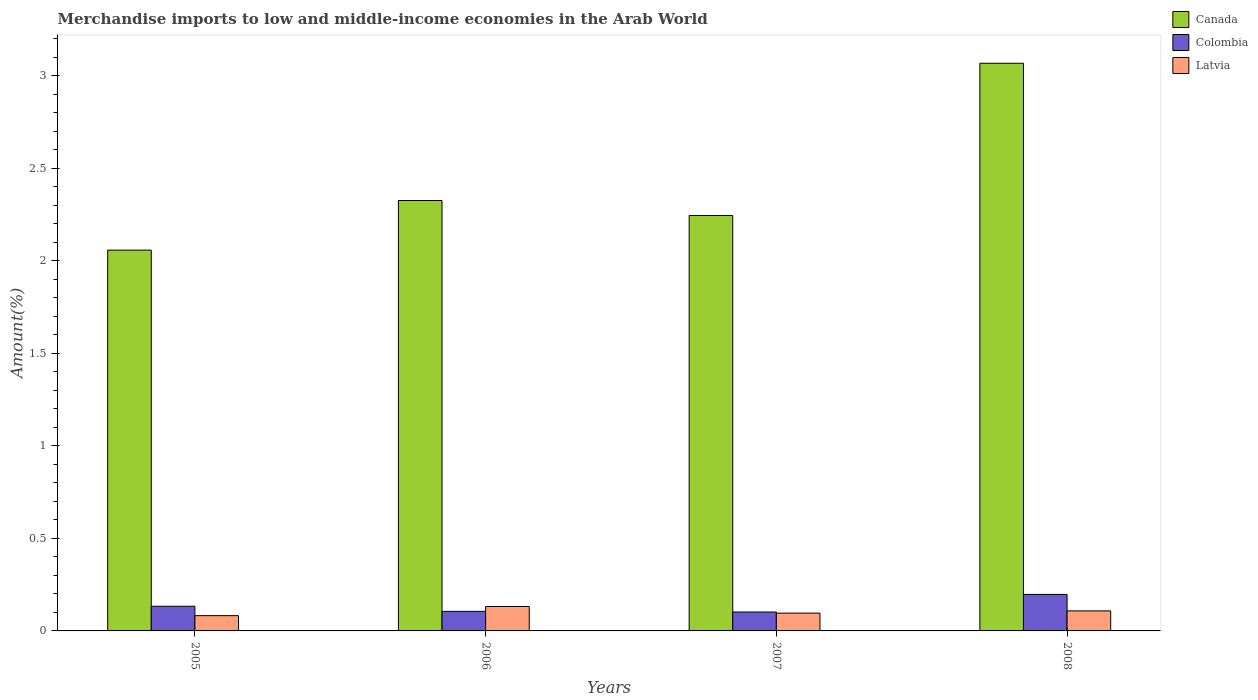How many different coloured bars are there?
Your answer should be very brief. 3. How many groups of bars are there?
Ensure brevity in your answer.  4. How many bars are there on the 2nd tick from the left?
Your answer should be very brief. 3. What is the label of the 1st group of bars from the left?
Provide a short and direct response. 2005. What is the percentage of amount earned from merchandise imports in Colombia in 2008?
Offer a very short reply. 0.2. Across all years, what is the maximum percentage of amount earned from merchandise imports in Latvia?
Give a very brief answer. 0.13. Across all years, what is the minimum percentage of amount earned from merchandise imports in Colombia?
Offer a very short reply. 0.1. In which year was the percentage of amount earned from merchandise imports in Canada maximum?
Provide a succinct answer. 2008. In which year was the percentage of amount earned from merchandise imports in Canada minimum?
Your answer should be compact. 2005. What is the total percentage of amount earned from merchandise imports in Latvia in the graph?
Ensure brevity in your answer.  0.42. What is the difference between the percentage of amount earned from merchandise imports in Latvia in 2006 and that in 2007?
Your answer should be very brief. 0.04. What is the difference between the percentage of amount earned from merchandise imports in Colombia in 2008 and the percentage of amount earned from merchandise imports in Canada in 2005?
Keep it short and to the point. -1.86. What is the average percentage of amount earned from merchandise imports in Colombia per year?
Your answer should be very brief. 0.13. In the year 2008, what is the difference between the percentage of amount earned from merchandise imports in Canada and percentage of amount earned from merchandise imports in Colombia?
Your answer should be compact. 2.87. In how many years, is the percentage of amount earned from merchandise imports in Colombia greater than 1.9 %?
Your response must be concise. 0. What is the ratio of the percentage of amount earned from merchandise imports in Canada in 2005 to that in 2006?
Your answer should be very brief. 0.88. Is the percentage of amount earned from merchandise imports in Colombia in 2005 less than that in 2006?
Offer a terse response. No. What is the difference between the highest and the second highest percentage of amount earned from merchandise imports in Colombia?
Provide a short and direct response. 0.06. What is the difference between the highest and the lowest percentage of amount earned from merchandise imports in Latvia?
Give a very brief answer. 0.05. What does the 1st bar from the left in 2006 represents?
Your answer should be very brief. Canada. What does the 1st bar from the right in 2007 represents?
Offer a terse response. Latvia. Are all the bars in the graph horizontal?
Provide a short and direct response. No. How many years are there in the graph?
Ensure brevity in your answer.  4. What is the difference between two consecutive major ticks on the Y-axis?
Give a very brief answer. 0.5. Where does the legend appear in the graph?
Make the answer very short. Top right. How are the legend labels stacked?
Your answer should be very brief. Vertical. What is the title of the graph?
Your answer should be compact. Merchandise imports to low and middle-income economies in the Arab World. What is the label or title of the X-axis?
Offer a very short reply. Years. What is the label or title of the Y-axis?
Give a very brief answer. Amount(%). What is the Amount(%) of Canada in 2005?
Ensure brevity in your answer.  2.06. What is the Amount(%) in Colombia in 2005?
Offer a very short reply. 0.13. What is the Amount(%) in Latvia in 2005?
Your answer should be very brief. 0.08. What is the Amount(%) in Canada in 2006?
Keep it short and to the point. 2.33. What is the Amount(%) of Colombia in 2006?
Keep it short and to the point. 0.11. What is the Amount(%) in Latvia in 2006?
Your response must be concise. 0.13. What is the Amount(%) in Canada in 2007?
Keep it short and to the point. 2.25. What is the Amount(%) of Colombia in 2007?
Ensure brevity in your answer.  0.1. What is the Amount(%) of Latvia in 2007?
Provide a short and direct response. 0.1. What is the Amount(%) of Canada in 2008?
Keep it short and to the point. 3.07. What is the Amount(%) of Colombia in 2008?
Provide a succinct answer. 0.2. What is the Amount(%) of Latvia in 2008?
Provide a succinct answer. 0.11. Across all years, what is the maximum Amount(%) of Canada?
Make the answer very short. 3.07. Across all years, what is the maximum Amount(%) of Colombia?
Your response must be concise. 0.2. Across all years, what is the maximum Amount(%) in Latvia?
Your answer should be very brief. 0.13. Across all years, what is the minimum Amount(%) in Canada?
Keep it short and to the point. 2.06. Across all years, what is the minimum Amount(%) of Colombia?
Provide a short and direct response. 0.1. Across all years, what is the minimum Amount(%) in Latvia?
Provide a succinct answer. 0.08. What is the total Amount(%) in Canada in the graph?
Keep it short and to the point. 9.7. What is the total Amount(%) of Colombia in the graph?
Your response must be concise. 0.54. What is the total Amount(%) of Latvia in the graph?
Provide a succinct answer. 0.42. What is the difference between the Amount(%) of Canada in 2005 and that in 2006?
Make the answer very short. -0.27. What is the difference between the Amount(%) of Colombia in 2005 and that in 2006?
Provide a succinct answer. 0.03. What is the difference between the Amount(%) of Latvia in 2005 and that in 2006?
Offer a very short reply. -0.05. What is the difference between the Amount(%) in Canada in 2005 and that in 2007?
Provide a succinct answer. -0.19. What is the difference between the Amount(%) of Colombia in 2005 and that in 2007?
Your answer should be compact. 0.03. What is the difference between the Amount(%) in Latvia in 2005 and that in 2007?
Give a very brief answer. -0.01. What is the difference between the Amount(%) in Canada in 2005 and that in 2008?
Give a very brief answer. -1.01. What is the difference between the Amount(%) in Colombia in 2005 and that in 2008?
Offer a terse response. -0.06. What is the difference between the Amount(%) of Latvia in 2005 and that in 2008?
Keep it short and to the point. -0.03. What is the difference between the Amount(%) of Canada in 2006 and that in 2007?
Provide a succinct answer. 0.08. What is the difference between the Amount(%) of Colombia in 2006 and that in 2007?
Provide a short and direct response. 0. What is the difference between the Amount(%) of Latvia in 2006 and that in 2007?
Provide a short and direct response. 0.04. What is the difference between the Amount(%) of Canada in 2006 and that in 2008?
Give a very brief answer. -0.74. What is the difference between the Amount(%) of Colombia in 2006 and that in 2008?
Your answer should be compact. -0.09. What is the difference between the Amount(%) in Latvia in 2006 and that in 2008?
Ensure brevity in your answer.  0.02. What is the difference between the Amount(%) of Canada in 2007 and that in 2008?
Keep it short and to the point. -0.82. What is the difference between the Amount(%) in Colombia in 2007 and that in 2008?
Give a very brief answer. -0.1. What is the difference between the Amount(%) of Latvia in 2007 and that in 2008?
Provide a succinct answer. -0.01. What is the difference between the Amount(%) of Canada in 2005 and the Amount(%) of Colombia in 2006?
Provide a succinct answer. 1.95. What is the difference between the Amount(%) of Canada in 2005 and the Amount(%) of Latvia in 2006?
Keep it short and to the point. 1.93. What is the difference between the Amount(%) of Colombia in 2005 and the Amount(%) of Latvia in 2006?
Ensure brevity in your answer.  0. What is the difference between the Amount(%) of Canada in 2005 and the Amount(%) of Colombia in 2007?
Offer a very short reply. 1.96. What is the difference between the Amount(%) of Canada in 2005 and the Amount(%) of Latvia in 2007?
Make the answer very short. 1.96. What is the difference between the Amount(%) of Colombia in 2005 and the Amount(%) of Latvia in 2007?
Offer a very short reply. 0.04. What is the difference between the Amount(%) in Canada in 2005 and the Amount(%) in Colombia in 2008?
Ensure brevity in your answer.  1.86. What is the difference between the Amount(%) of Canada in 2005 and the Amount(%) of Latvia in 2008?
Your answer should be compact. 1.95. What is the difference between the Amount(%) of Colombia in 2005 and the Amount(%) of Latvia in 2008?
Your response must be concise. 0.03. What is the difference between the Amount(%) of Canada in 2006 and the Amount(%) of Colombia in 2007?
Give a very brief answer. 2.22. What is the difference between the Amount(%) in Canada in 2006 and the Amount(%) in Latvia in 2007?
Give a very brief answer. 2.23. What is the difference between the Amount(%) in Colombia in 2006 and the Amount(%) in Latvia in 2007?
Keep it short and to the point. 0.01. What is the difference between the Amount(%) of Canada in 2006 and the Amount(%) of Colombia in 2008?
Ensure brevity in your answer.  2.13. What is the difference between the Amount(%) in Canada in 2006 and the Amount(%) in Latvia in 2008?
Offer a terse response. 2.22. What is the difference between the Amount(%) in Colombia in 2006 and the Amount(%) in Latvia in 2008?
Offer a very short reply. -0. What is the difference between the Amount(%) in Canada in 2007 and the Amount(%) in Colombia in 2008?
Give a very brief answer. 2.05. What is the difference between the Amount(%) of Canada in 2007 and the Amount(%) of Latvia in 2008?
Your answer should be very brief. 2.14. What is the difference between the Amount(%) of Colombia in 2007 and the Amount(%) of Latvia in 2008?
Make the answer very short. -0.01. What is the average Amount(%) in Canada per year?
Offer a very short reply. 2.42. What is the average Amount(%) in Colombia per year?
Offer a terse response. 0.13. What is the average Amount(%) in Latvia per year?
Offer a terse response. 0.1. In the year 2005, what is the difference between the Amount(%) in Canada and Amount(%) in Colombia?
Your response must be concise. 1.92. In the year 2005, what is the difference between the Amount(%) in Canada and Amount(%) in Latvia?
Your answer should be compact. 1.98. In the year 2005, what is the difference between the Amount(%) in Colombia and Amount(%) in Latvia?
Make the answer very short. 0.05. In the year 2006, what is the difference between the Amount(%) of Canada and Amount(%) of Colombia?
Ensure brevity in your answer.  2.22. In the year 2006, what is the difference between the Amount(%) in Canada and Amount(%) in Latvia?
Give a very brief answer. 2.19. In the year 2006, what is the difference between the Amount(%) of Colombia and Amount(%) of Latvia?
Make the answer very short. -0.03. In the year 2007, what is the difference between the Amount(%) in Canada and Amount(%) in Colombia?
Provide a succinct answer. 2.14. In the year 2007, what is the difference between the Amount(%) in Canada and Amount(%) in Latvia?
Your response must be concise. 2.15. In the year 2007, what is the difference between the Amount(%) of Colombia and Amount(%) of Latvia?
Offer a very short reply. 0.01. In the year 2008, what is the difference between the Amount(%) in Canada and Amount(%) in Colombia?
Offer a very short reply. 2.87. In the year 2008, what is the difference between the Amount(%) in Canada and Amount(%) in Latvia?
Ensure brevity in your answer.  2.96. In the year 2008, what is the difference between the Amount(%) of Colombia and Amount(%) of Latvia?
Ensure brevity in your answer.  0.09. What is the ratio of the Amount(%) in Canada in 2005 to that in 2006?
Ensure brevity in your answer.  0.88. What is the ratio of the Amount(%) in Colombia in 2005 to that in 2006?
Ensure brevity in your answer.  1.26. What is the ratio of the Amount(%) in Latvia in 2005 to that in 2006?
Provide a short and direct response. 0.62. What is the ratio of the Amount(%) in Canada in 2005 to that in 2007?
Offer a very short reply. 0.92. What is the ratio of the Amount(%) in Colombia in 2005 to that in 2007?
Ensure brevity in your answer.  1.31. What is the ratio of the Amount(%) in Latvia in 2005 to that in 2007?
Ensure brevity in your answer.  0.86. What is the ratio of the Amount(%) of Canada in 2005 to that in 2008?
Your response must be concise. 0.67. What is the ratio of the Amount(%) in Colombia in 2005 to that in 2008?
Your response must be concise. 0.68. What is the ratio of the Amount(%) of Latvia in 2005 to that in 2008?
Your answer should be compact. 0.76. What is the ratio of the Amount(%) in Canada in 2006 to that in 2007?
Give a very brief answer. 1.04. What is the ratio of the Amount(%) in Colombia in 2006 to that in 2007?
Your response must be concise. 1.03. What is the ratio of the Amount(%) of Latvia in 2006 to that in 2007?
Offer a terse response. 1.37. What is the ratio of the Amount(%) of Canada in 2006 to that in 2008?
Offer a very short reply. 0.76. What is the ratio of the Amount(%) in Colombia in 2006 to that in 2008?
Your answer should be very brief. 0.54. What is the ratio of the Amount(%) of Latvia in 2006 to that in 2008?
Provide a succinct answer. 1.22. What is the ratio of the Amount(%) of Canada in 2007 to that in 2008?
Your answer should be very brief. 0.73. What is the ratio of the Amount(%) of Colombia in 2007 to that in 2008?
Provide a succinct answer. 0.52. What is the ratio of the Amount(%) in Latvia in 2007 to that in 2008?
Offer a terse response. 0.89. What is the difference between the highest and the second highest Amount(%) of Canada?
Your response must be concise. 0.74. What is the difference between the highest and the second highest Amount(%) in Colombia?
Your answer should be compact. 0.06. What is the difference between the highest and the second highest Amount(%) in Latvia?
Offer a terse response. 0.02. What is the difference between the highest and the lowest Amount(%) of Canada?
Offer a terse response. 1.01. What is the difference between the highest and the lowest Amount(%) in Colombia?
Your answer should be compact. 0.1. What is the difference between the highest and the lowest Amount(%) of Latvia?
Your answer should be compact. 0.05. 